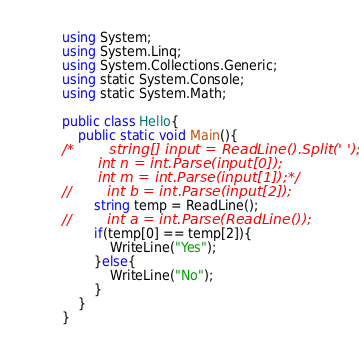Convert code to text. <code><loc_0><loc_0><loc_500><loc_500><_C#_>using System;
using System.Linq;
using System.Collections.Generic;
using static System.Console;
using static System.Math;
 
public class Hello{
    public static void Main(){
/*        string[] input = ReadLine().Split(' ');
        int n = int.Parse(input[0]);
        int m = int.Parse(input[1]);*/
//        int b = int.Parse(input[2]);
        string temp = ReadLine();
//        int a = int.Parse(ReadLine());
        if(temp[0] == temp[2]){
            WriteLine("Yes");
        }else{
            WriteLine("No");
        }
    }
}</code> 